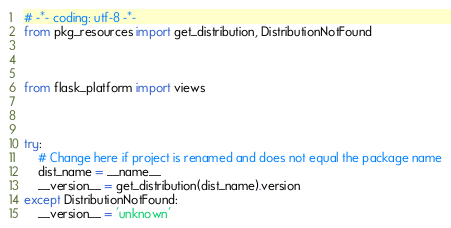Convert code to text. <code><loc_0><loc_0><loc_500><loc_500><_Python_># -*- coding: utf-8 -*-
from pkg_resources import get_distribution, DistributionNotFound



from flask_platform import views



try:
    # Change here if project is renamed and does not equal the package name
    dist_name = __name__
    __version__ = get_distribution(dist_name).version
except DistributionNotFound:
    __version__ = 'unknown'
</code> 